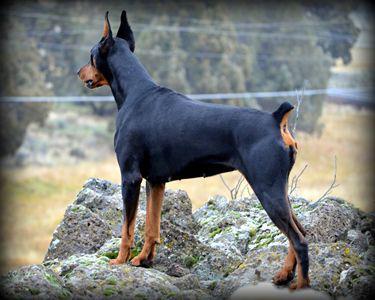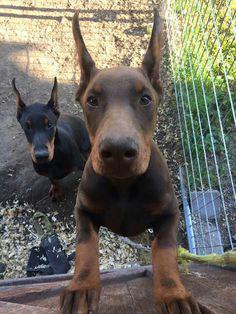The first image is the image on the left, the second image is the image on the right. Given the left and right images, does the statement "The right image contains exactly two dogs." hold true? Answer yes or no. Yes. 